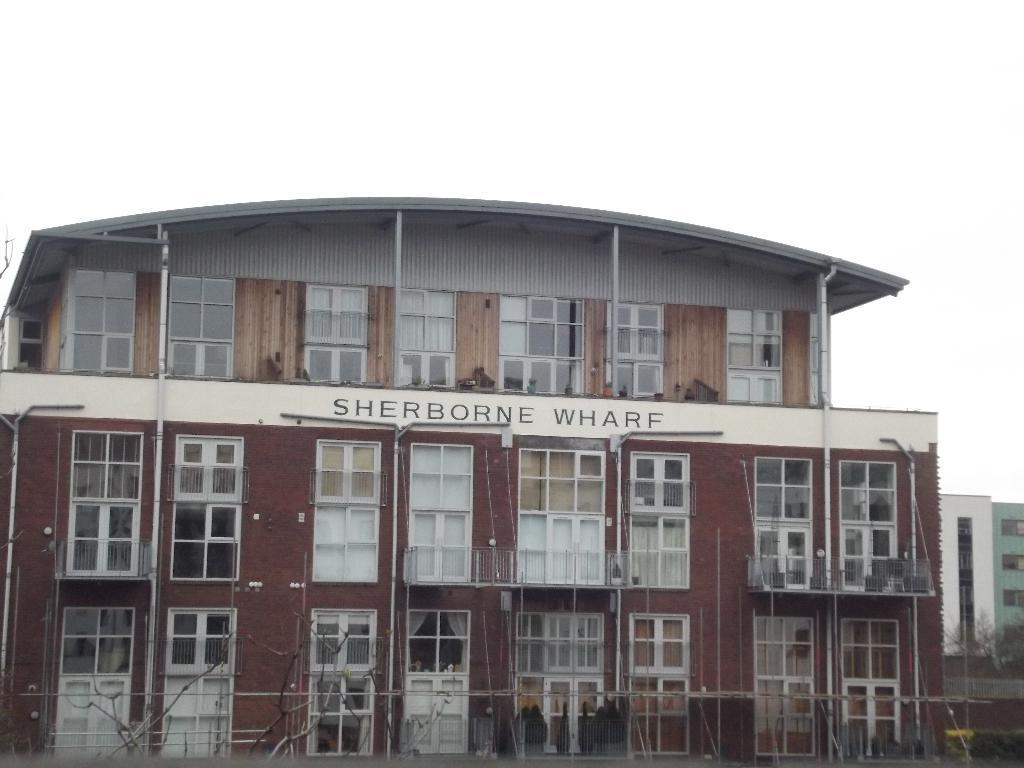What type of structure is visible in the image? There is a building in the image. What feature can be seen on the building's exterior? The building has glass windows and glass doors. Is there any text or writing on the building? Yes, there is text or writing on the building. Can you tell me who the writer is in the building's bedroom? There is no bedroom or writer mentioned in the image; it only features a building with glass windows and doors and text or writing on its exterior. 